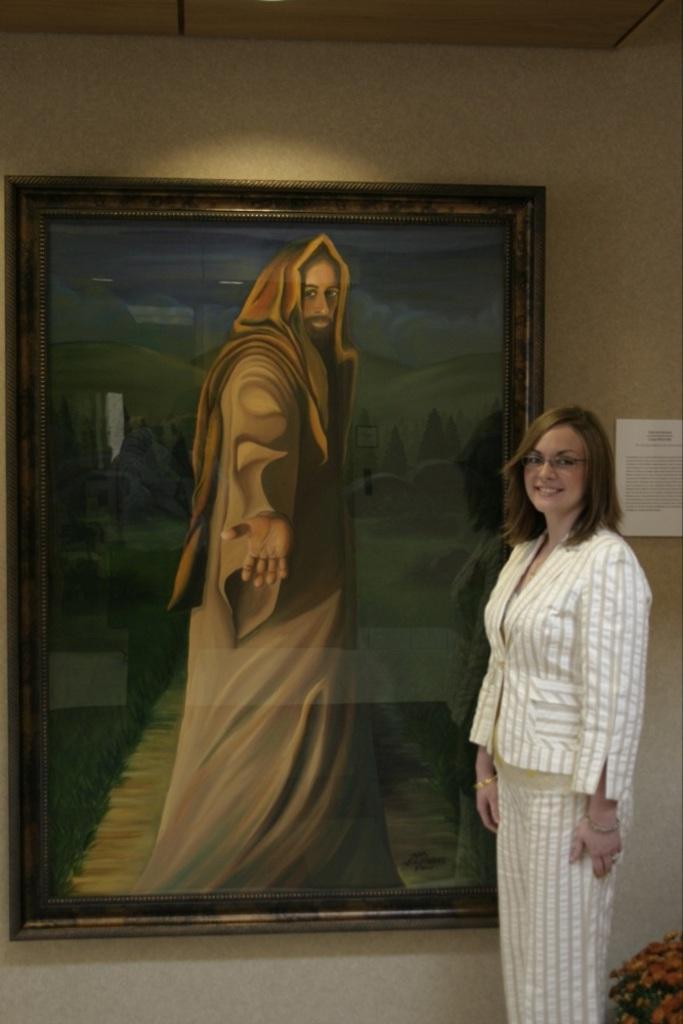Please provide a concise description of this image. In the image there is a woman standing in front of a portrait that is attached to the wall and beside the portrait there is some notice. 